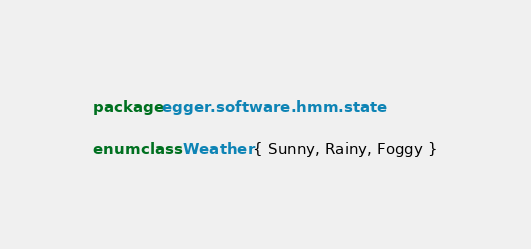Convert code to text. <code><loc_0><loc_0><loc_500><loc_500><_Kotlin_>package egger.software.hmm.state

enum class Weather { Sunny, Rainy, Foggy }</code> 